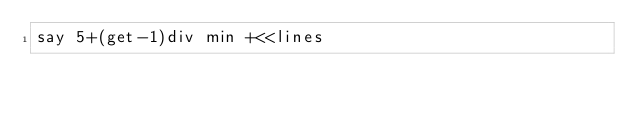Convert code to text. <code><loc_0><loc_0><loc_500><loc_500><_Perl_>say 5+(get-1)div min +<<lines</code> 